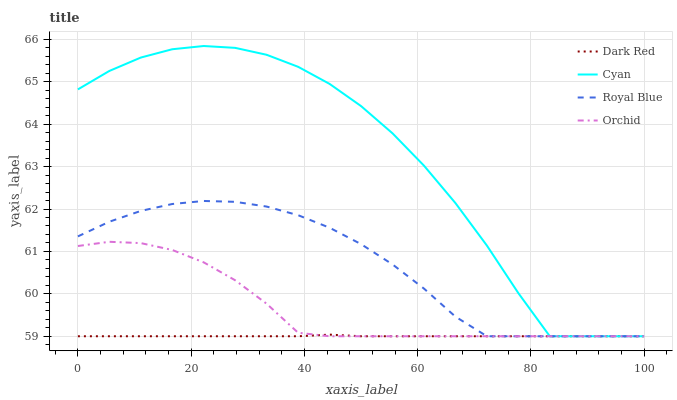Does Dark Red have the minimum area under the curve?
Answer yes or no. Yes. Does Cyan have the maximum area under the curve?
Answer yes or no. Yes. Does Orchid have the minimum area under the curve?
Answer yes or no. No. Does Orchid have the maximum area under the curve?
Answer yes or no. No. Is Dark Red the smoothest?
Answer yes or no. Yes. Is Cyan the roughest?
Answer yes or no. Yes. Is Orchid the smoothest?
Answer yes or no. No. Is Orchid the roughest?
Answer yes or no. No. Does Dark Red have the lowest value?
Answer yes or no. Yes. Does Cyan have the highest value?
Answer yes or no. Yes. Does Orchid have the highest value?
Answer yes or no. No. Does Royal Blue intersect Dark Red?
Answer yes or no. Yes. Is Royal Blue less than Dark Red?
Answer yes or no. No. Is Royal Blue greater than Dark Red?
Answer yes or no. No. 